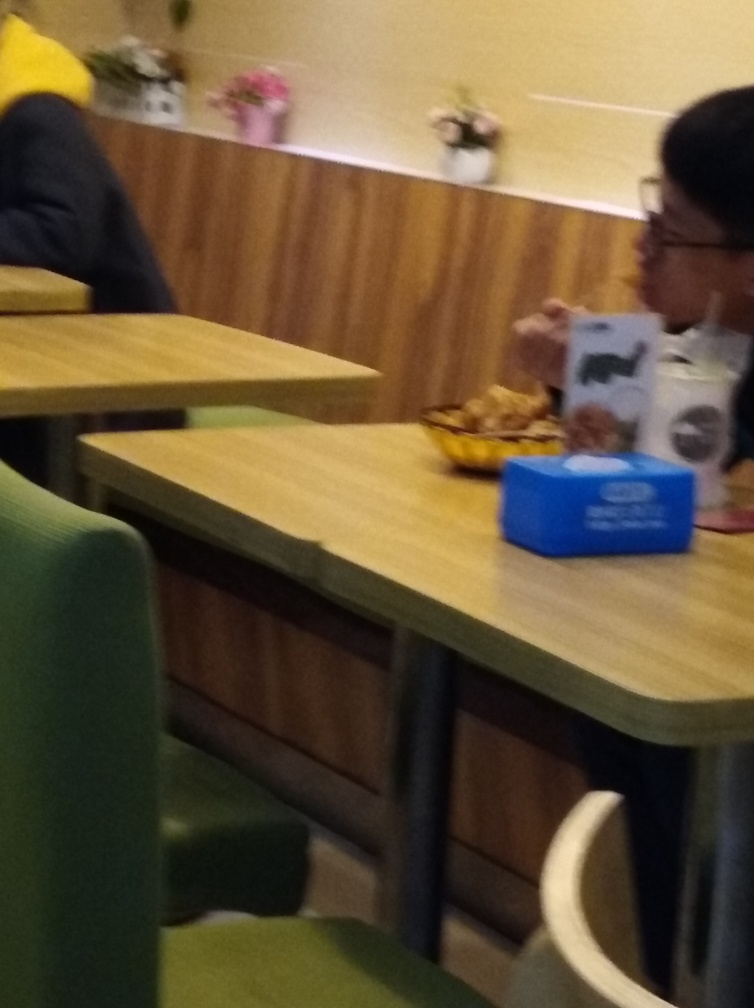Is the image blurry?
A. Yes
B. Occasionally
C. Partially
Answer with the option's letter from the given choices directly.
 A. 